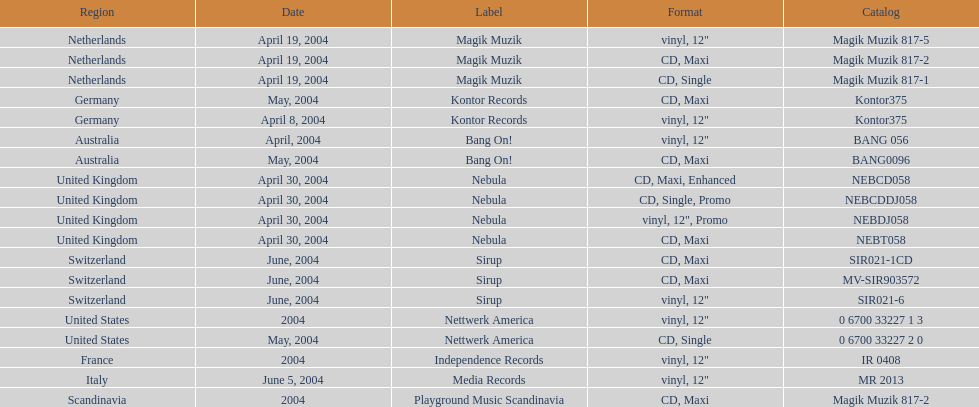Above australia, which region can be found? Germany. 